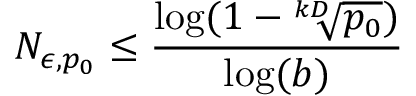<formula> <loc_0><loc_0><loc_500><loc_500>N _ { \epsilon , p _ { 0 } } \leq \frac { \log ( 1 - \sqrt { [ } k D ] { p _ { 0 } } ) } { \log ( b ) }</formula> 